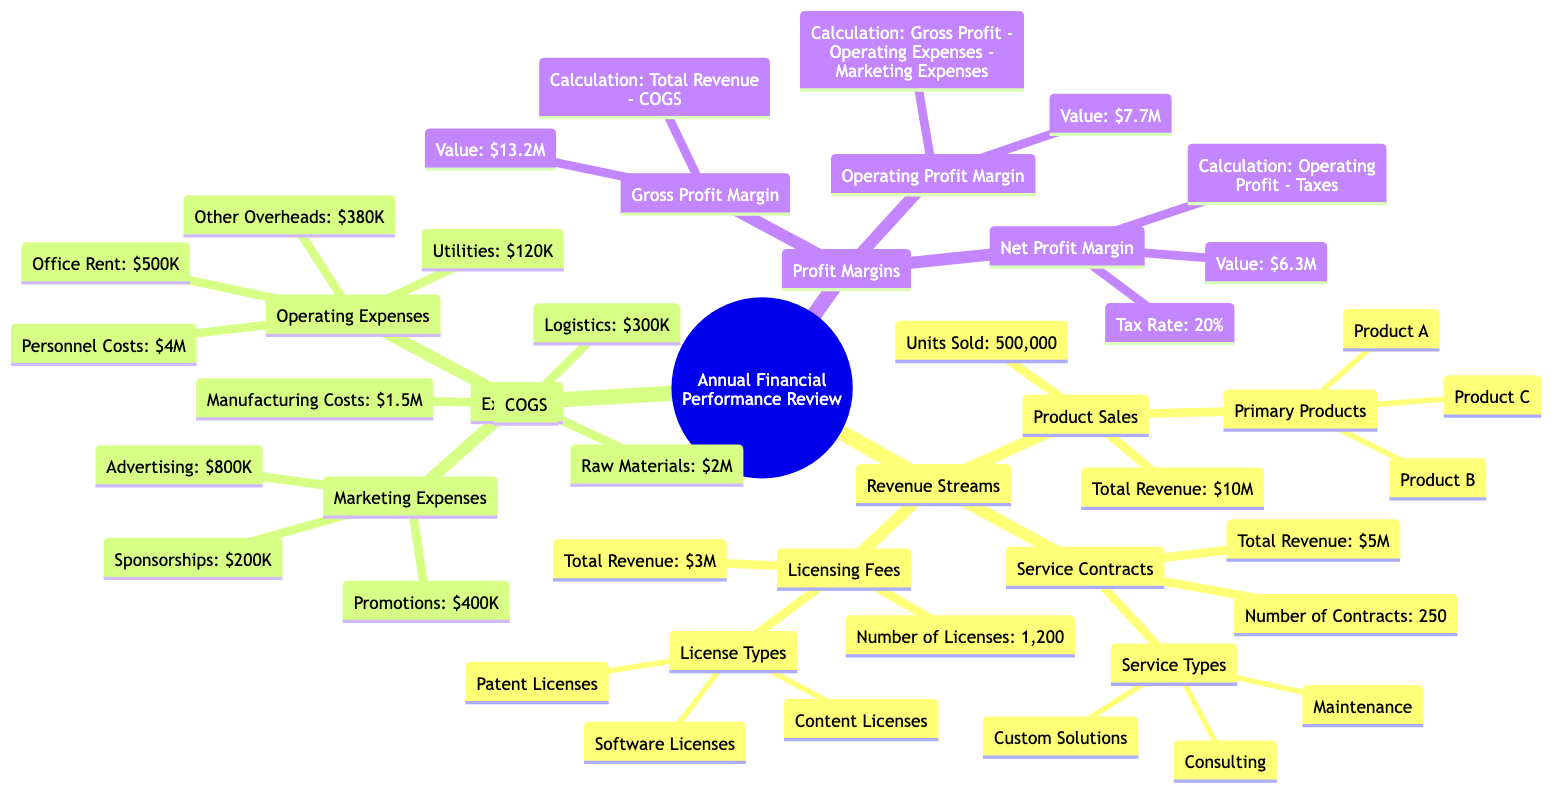What is the total revenue from Product Sales? The total revenue from Product Sales is listed in the node under Revenue Streams > Product Sales. It specifically states that the Total Revenue is $10,000,000.
Answer: $10,000,000 How many units were sold in Product Sales? The number of units sold is found in the node under Revenue Streams > Product Sales. It directly states that the Units Sold is 500,000 units.
Answer: 500,000 units What are the primary products sold? The primary products can be found under Revenue Streams > Product Sales. The specific products listed are Product A, Product B, and Product C.
Answer: Product A, Product B, Product C What are the main components of Operating Expenses? Operating Expenses are broken down into specific categories under Expenses > Operating Expenses. The main components are Personnel Costs, Office Rent, Utilities, and Other Overheads.
Answer: Personnel Costs, Office Rent, Utilities, Other Overheads What is the calculation for Gross Profit Margin? The calculation for Gross Profit Margin is stated in the node under Profit Margins > Gross Profit Margin. It specifies that it is calculated as Total Revenue - COGS.
Answer: Total Revenue - COGS What is the value of the Operating Profit Margin? The value of the Operating Profit Margin is specified in the node under Profit Margins > Operating Profit Margin. It states that the value is $7,700,000.
Answer: $7,700,000 How does the Net Profit Margin relate to Operating Profit? The calculation for Net Profit Margin is outlined in the node under Profit Margins > Net Profit Margin, which states it is calculated as Operating Profit - Taxes. This indicates a direct relationship between them, as the Net Profit Margin is derived from the Operating Profit.
Answer: Operating Profit - Taxes What is included in Marketing Expenses? The Marketing Expenses node under Expenses categorizes the expenses into Advertising, Promotions, and Sponsorships. These items are specifically mentioned in the diagram.
Answer: Advertising, Promotions, Sponsorships What is the total amount of COGS? COGS (Cost of Goods Sold) can be found directly under Expenses. The total amount is the sum of Raw Materials, Manufacturing Costs, and Logistics, which are listed as $2,000,000, $1,500,000, and $300,000 respectively, summing up to $3,800,000.
Answer: $3,800,000 